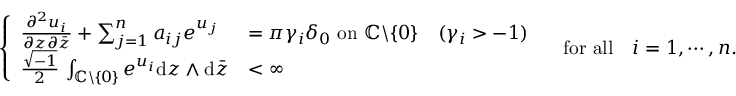Convert formula to latex. <formula><loc_0><loc_0><loc_500><loc_500>\left \{ \begin{array} { l l } { \frac { \partial ^ { 2 } u _ { i } } { \partial z \partial \bar { z } } + \sum _ { j = 1 } ^ { n } a _ { i j } e ^ { u _ { j } } } & { = \pi \gamma _ { i } \delta _ { 0 } \, o n \, { \mathbb { C } } \ \{ 0 \} \quad ( \gamma _ { i } > - 1 ) } \\ { \frac { \sqrt { - 1 } } { 2 } \, \int _ { { \mathbb { C } } \ \{ 0 \} } e ^ { u _ { i } } d z \wedge d \bar { z } } & { < \infty } \end{array} \quad f o r a l l \quad i = 1 , \cdots , n .</formula> 